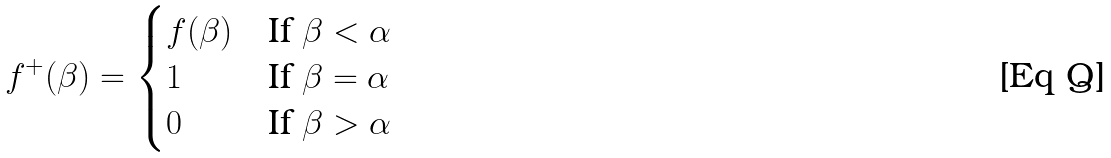Convert formula to latex. <formula><loc_0><loc_0><loc_500><loc_500>f ^ { + } ( \beta ) = \begin{cases} f ( \beta ) & \text {If $\beta < \alpha$} \\ 1 & \text {If $\beta=\alpha$} \\ 0 & \text {If $\beta> \alpha$} \end{cases}</formula> 